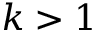<formula> <loc_0><loc_0><loc_500><loc_500>k > 1</formula> 